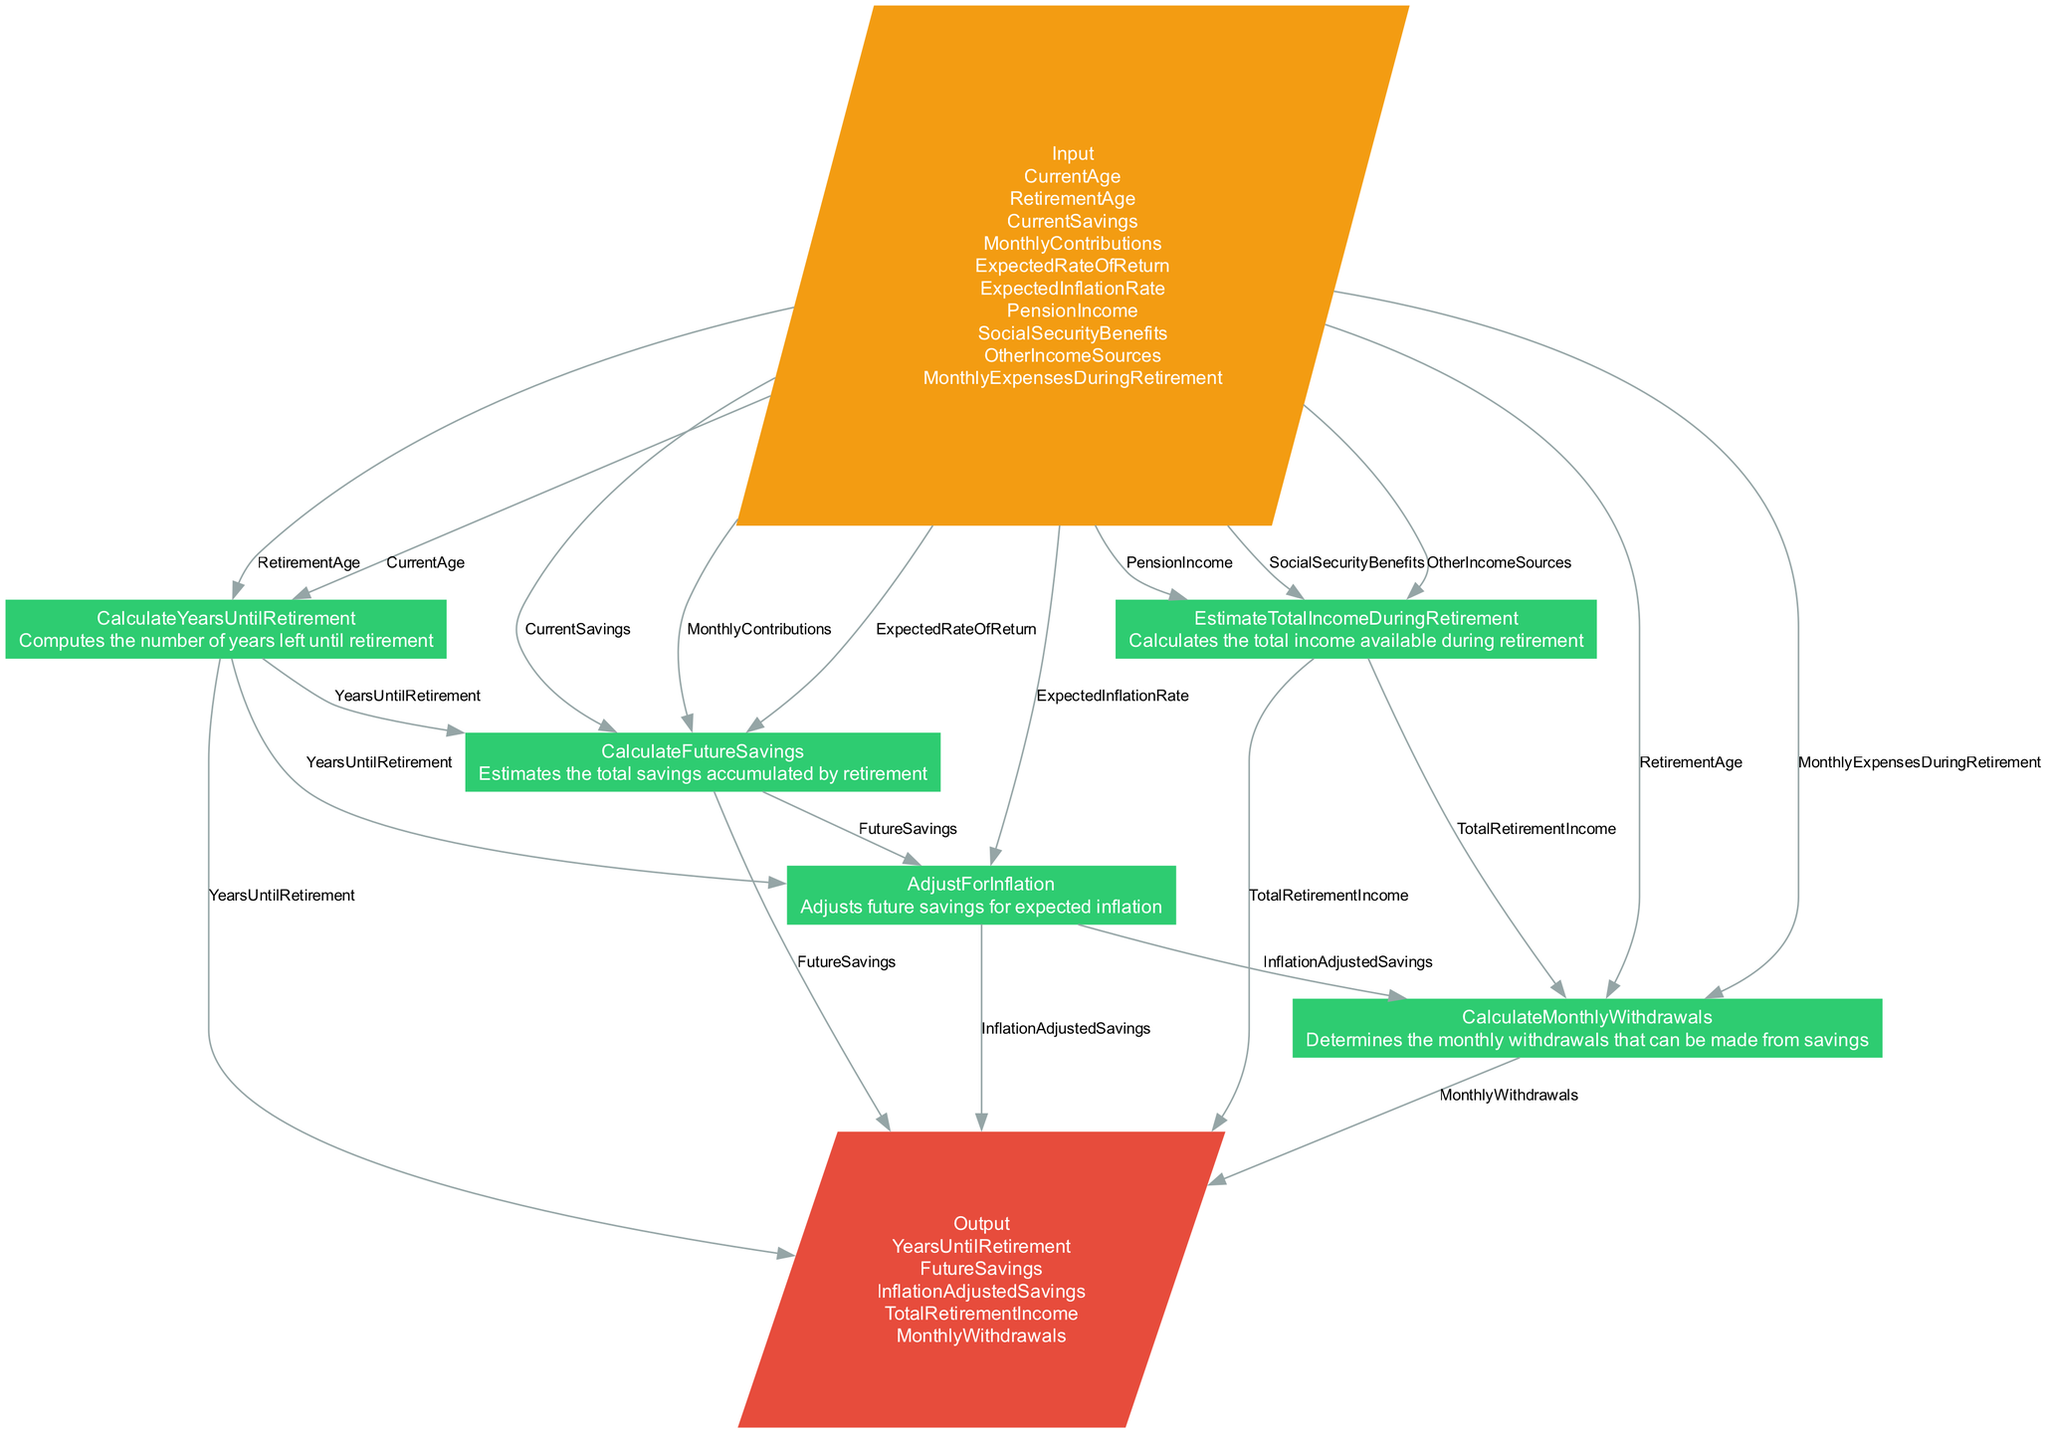What are the inputs for the Retirement Planning Calculator? The diagram lists the inputs for the Retirement Planning Calculator as: Current Age, Retirement Age, Current Savings, Monthly Contributions, Expected Rate of Return, Expected Inflation Rate, Pension Income, Social Security Benefits, Other Income Sources, and Monthly Expenses During Retirement.
Answer: Current Age, Retirement Age, Current Savings, Monthly Contributions, Expected Rate of Return, Expected Inflation Rate, Pension Income, Social Security Benefits, Other Income Sources, Monthly Expenses During Retirement What is the output from the Calculate Monthly Withdrawals process? This process outputs the Monthly Withdrawals, which are determined based on inputs from previous processes including Inflation Adjusted Savings, Retirement Age, Life Expectancy, Total Retirement Income, and Monthly Expenses During Retirement.
Answer: Monthly Withdrawals How many processes are involved in this flowchart? The flowchart contains five distinct processes: Calculate Years Until Retirement, Calculate Future Savings, Adjust For Inflation, Estimate Total Income During Retirement, and Calculate Monthly Withdrawals.
Answer: Five What is the first process in the flow of the diagram? The first process listed in the flow of the diagram is Calculate Years Until Retirement, which computes how many years are left until retirement based on Current Age and Retirement Age inputs.
Answer: Calculate Years Until Retirement Which process calculates future savings? The process named Calculate Future Savings estimates the total savings accumulated by retirement and takes inputs such as Current Savings, Monthly Contributions, Expected Rate of Return, and Years Until Retirement.
Answer: Calculate Future Savings What is adjusted for expected inflation in this flowchart? The flowchart details that the future savings, labeled as Future Savings, are adjusted for expected inflation in the Adjust For Inflation process, resulting in Inflation Adjusted Savings.
Answer: Future Savings What outputs depend on the Calculate Monthly Withdrawals process? The outputs of the Calculate Monthly Withdrawals process include Monthly Withdrawals, which depend on inputs from the prior processes, namely Inflation Adjusted Savings, Retirement Age, Life Expectancy, Total Retirement Income, and Monthly Expenses During Retirement.
Answer: Monthly Withdrawals Which process incorporates diverse income sources during retirement? The process called Estimate Total Income During Retirement calculates the total income available during retirement, including inputs such as Pension Income, Social Security Benefits, and Other Income Sources.
Answer: Estimate Total Income During Retirement What inputs are necessary for the Adjust For Inflation process? The Adjust For Inflation process requires Future Savings, Expected Inflation Rate, and Years Until Retirement as inputs to compute the Inflation Adjusted Savings.
Answer: Future Savings, Expected Inflation Rate, Years Until Retirement 